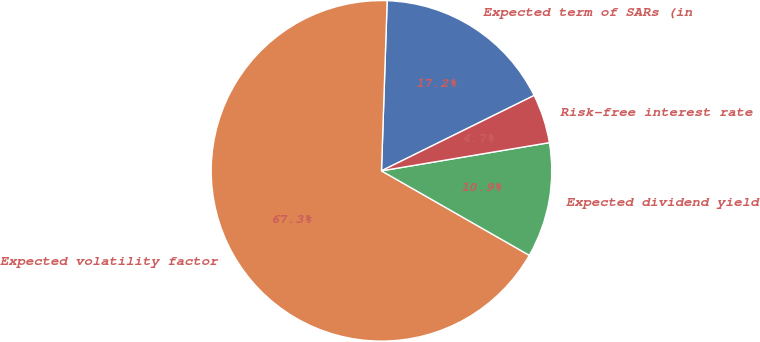<chart> <loc_0><loc_0><loc_500><loc_500><pie_chart><fcel>Expected term of SARs (in<fcel>Expected volatility factor<fcel>Expected dividend yield<fcel>Risk-free interest rate<nl><fcel>17.17%<fcel>67.27%<fcel>10.91%<fcel>4.65%<nl></chart> 